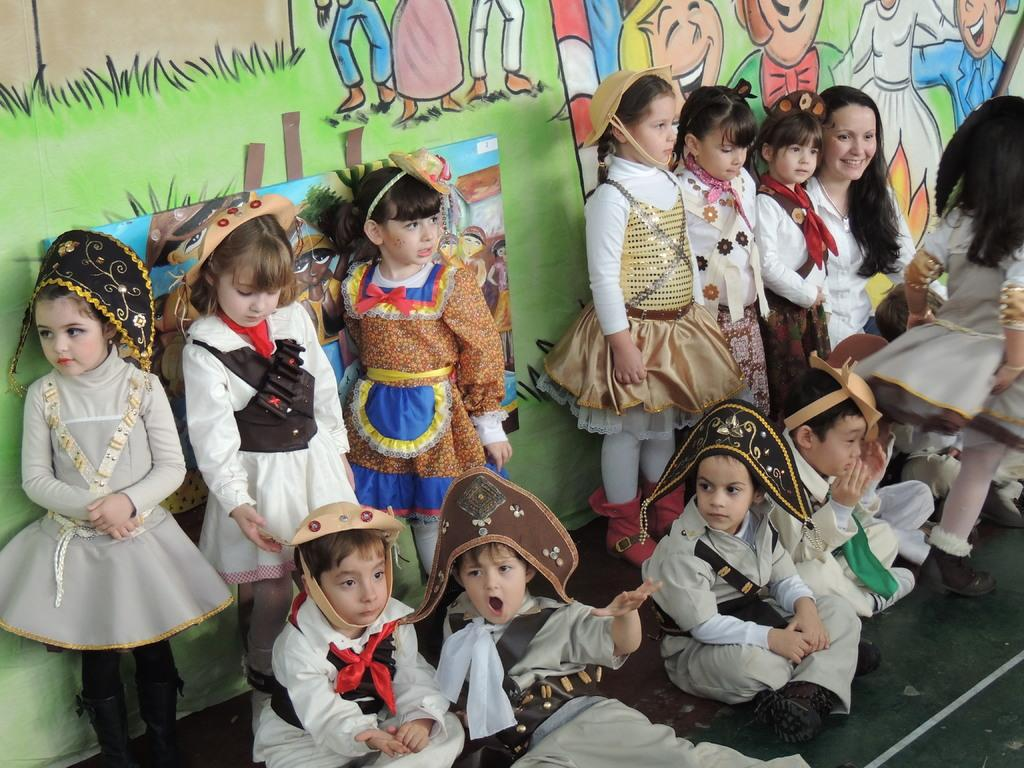What are the kids in the image doing? There are kids sitting and standing in the image. Can you describe the background of the image? There are paintings on the wall in the background of the image. What type of gate can be seen in the image? There is no gate present in the image. What journey are the kids taking in the image? There is no indication of a journey in the image; it simply shows kids sitting and standing. 